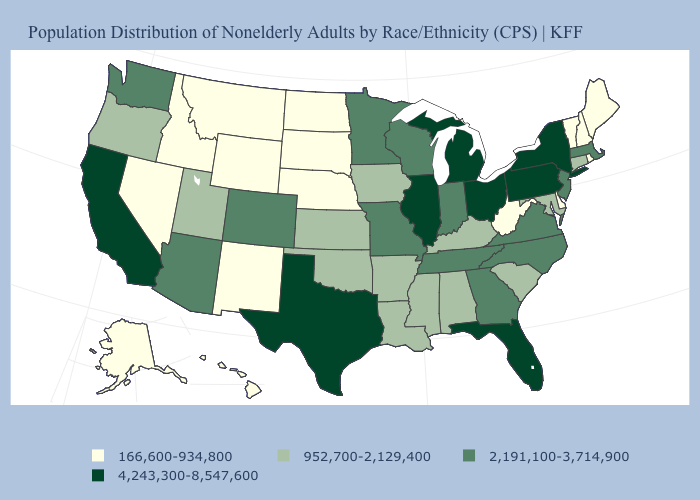What is the lowest value in the USA?
Short answer required. 166,600-934,800. What is the value of Nebraska?
Quick response, please. 166,600-934,800. Among the states that border West Virginia , which have the highest value?
Answer briefly. Ohio, Pennsylvania. Which states have the highest value in the USA?
Concise answer only. California, Florida, Illinois, Michigan, New York, Ohio, Pennsylvania, Texas. Does California have the highest value in the USA?
Short answer required. Yes. What is the highest value in the Northeast ?
Write a very short answer. 4,243,300-8,547,600. Among the states that border Missouri , does Oklahoma have the lowest value?
Quick response, please. No. What is the value of Hawaii?
Short answer required. 166,600-934,800. Among the states that border Virginia , does North Carolina have the highest value?
Keep it brief. Yes. What is the value of Florida?
Write a very short answer. 4,243,300-8,547,600. What is the value of Washington?
Give a very brief answer. 2,191,100-3,714,900. Does the map have missing data?
Answer briefly. No. What is the value of South Dakota?
Write a very short answer. 166,600-934,800. Does Arizona have the highest value in the West?
Give a very brief answer. No. What is the lowest value in the USA?
Keep it brief. 166,600-934,800. 